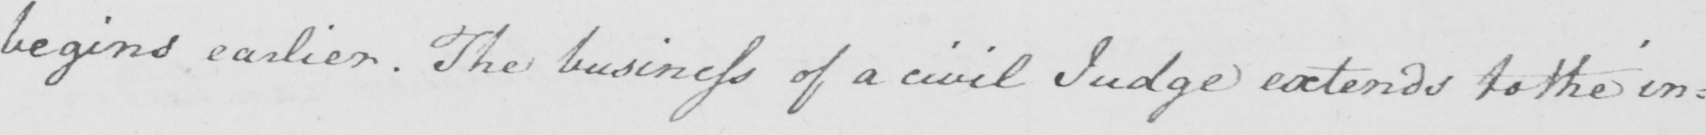Please transcribe the handwritten text in this image. begins earlier. The business of a civil Judge extends to the in= 